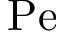<formula> <loc_0><loc_0><loc_500><loc_500>P e</formula> 